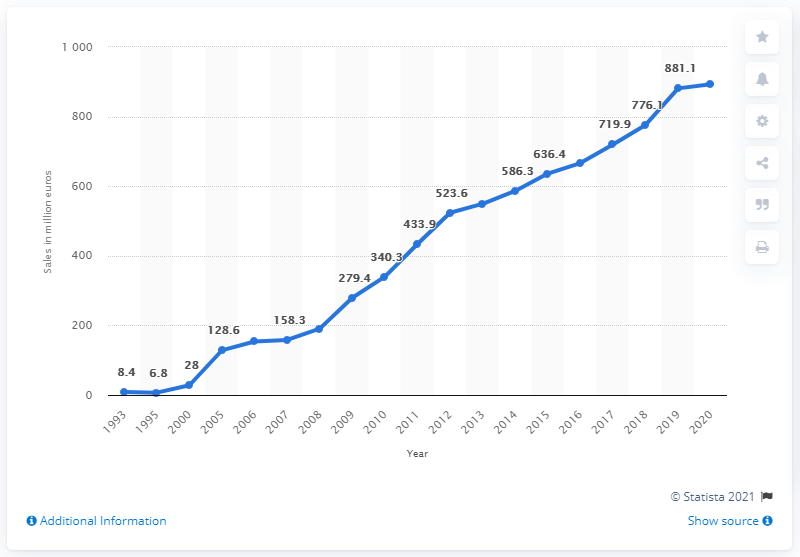Give some essential details in this illustration. In 2020, the sales of Puma accessories were 892.7 million. 